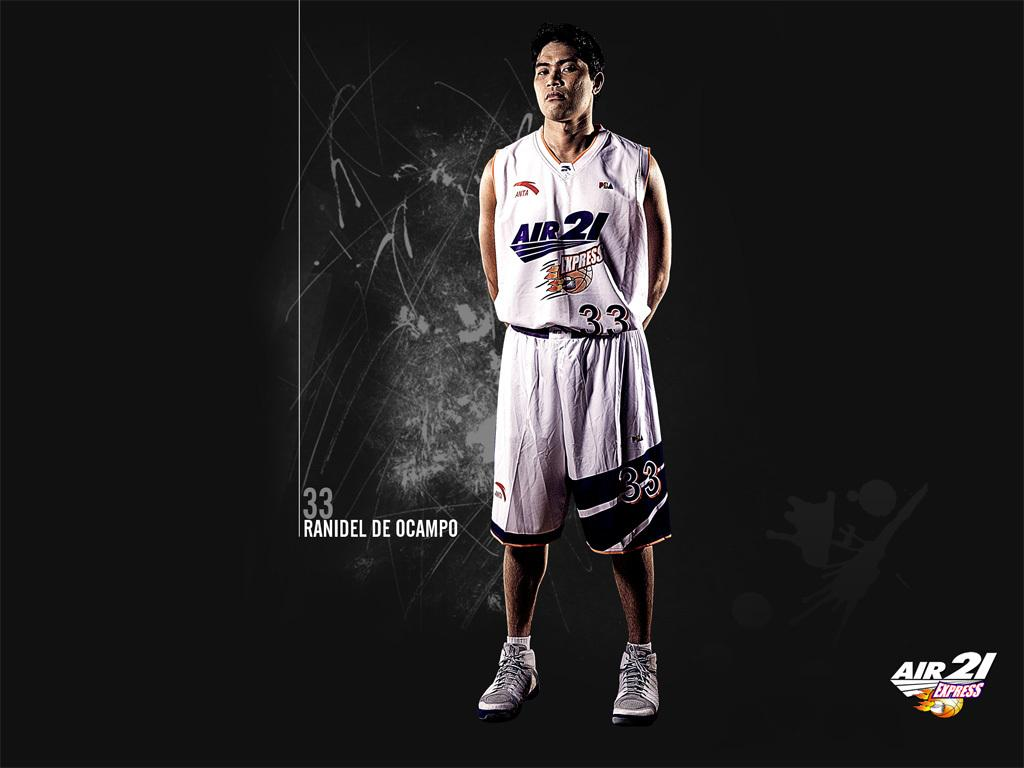<image>
Offer a succinct explanation of the picture presented. Athlete wearing a jersey that says Air21 on it. 